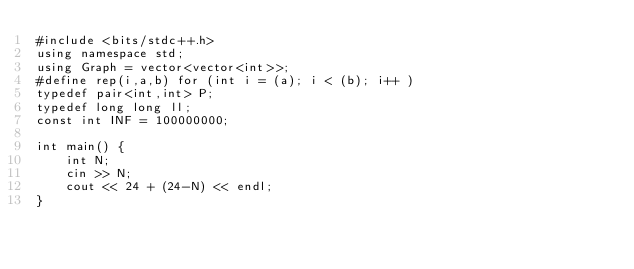Convert code to text. <code><loc_0><loc_0><loc_500><loc_500><_C++_>#include <bits/stdc++.h>
using namespace std;
using Graph = vector<vector<int>>;
#define rep(i,a,b) for (int i = (a); i < (b); i++ )
typedef pair<int,int> P;
typedef long long ll;
const int INF = 100000000;

int main() {
    int N;
    cin >> N;
    cout << 24 + (24-N) << endl;
}</code> 